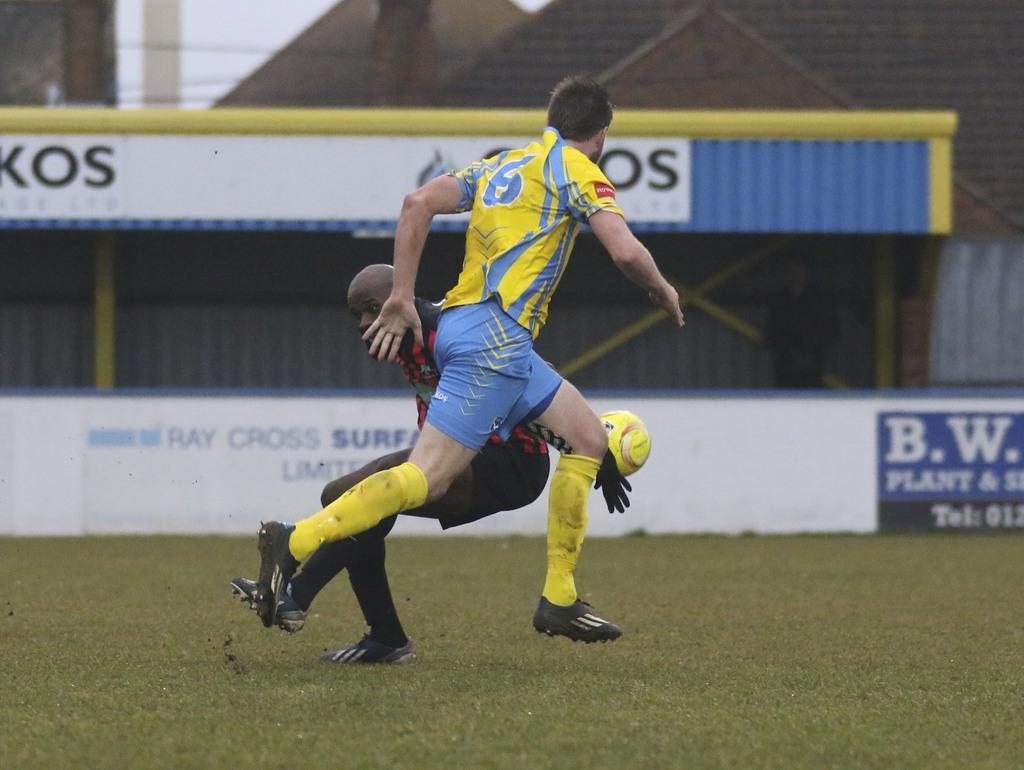What activity are the two guys in the image engaged in? The two guys in the image are playing football. What can be seen in the background of the image? There is a stand named "RAY CROSS SURF" in the background of the image. Where was the image taken? The image was taken in a football stadium. What type of sweater is the guy on the left wearing in the image? There is no information about the clothing of the guys in the image, so we cannot determine if they are wearing sweaters or any specific type of clothing. 